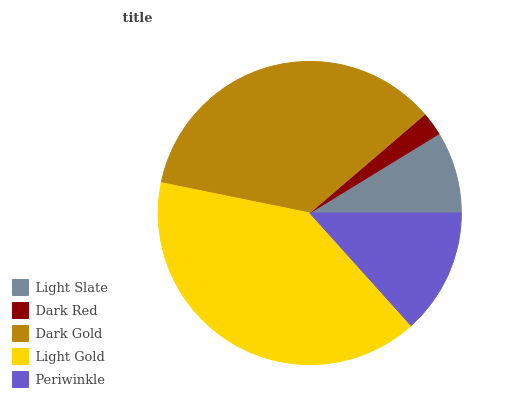Is Dark Red the minimum?
Answer yes or no. Yes. Is Light Gold the maximum?
Answer yes or no. Yes. Is Dark Gold the minimum?
Answer yes or no. No. Is Dark Gold the maximum?
Answer yes or no. No. Is Dark Gold greater than Dark Red?
Answer yes or no. Yes. Is Dark Red less than Dark Gold?
Answer yes or no. Yes. Is Dark Red greater than Dark Gold?
Answer yes or no. No. Is Dark Gold less than Dark Red?
Answer yes or no. No. Is Periwinkle the high median?
Answer yes or no. Yes. Is Periwinkle the low median?
Answer yes or no. Yes. Is Light Gold the high median?
Answer yes or no. No. Is Dark Gold the low median?
Answer yes or no. No. 